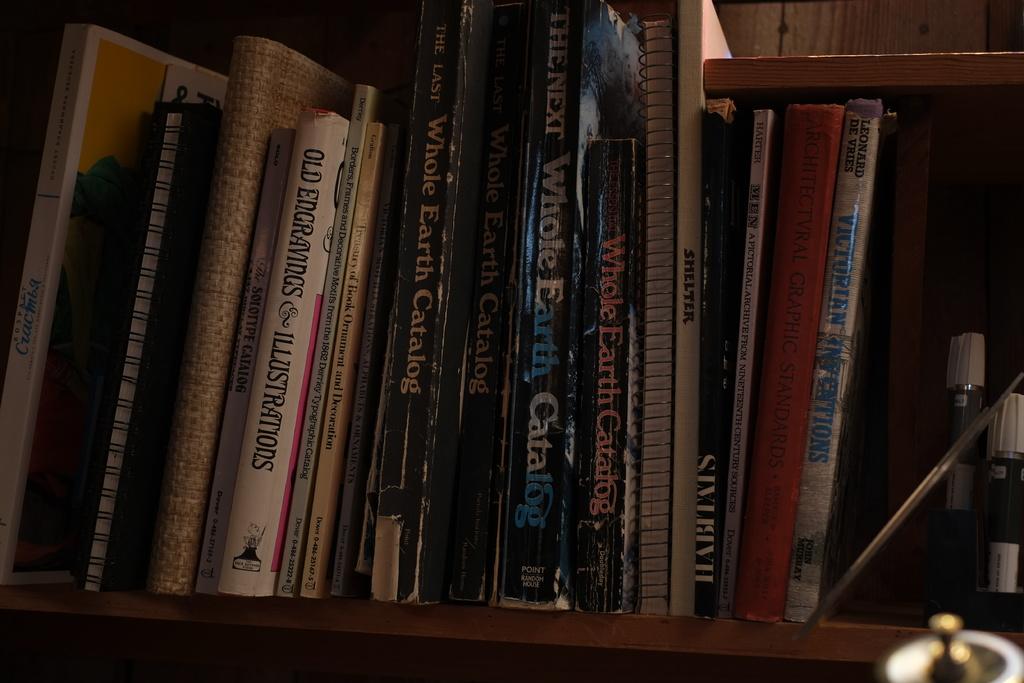What type of catalog is shown?
Give a very brief answer. Whole earth. What is the name of one of the black books?
Provide a short and direct response. Whole earth catalog. 